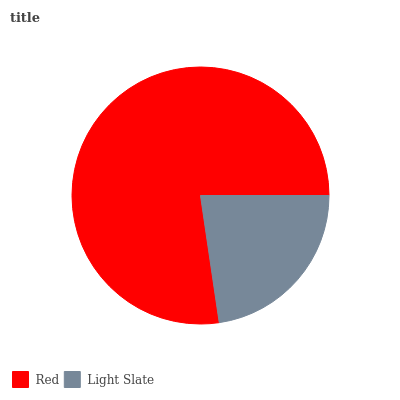Is Light Slate the minimum?
Answer yes or no. Yes. Is Red the maximum?
Answer yes or no. Yes. Is Light Slate the maximum?
Answer yes or no. No. Is Red greater than Light Slate?
Answer yes or no. Yes. Is Light Slate less than Red?
Answer yes or no. Yes. Is Light Slate greater than Red?
Answer yes or no. No. Is Red less than Light Slate?
Answer yes or no. No. Is Red the high median?
Answer yes or no. Yes. Is Light Slate the low median?
Answer yes or no. Yes. Is Light Slate the high median?
Answer yes or no. No. Is Red the low median?
Answer yes or no. No. 